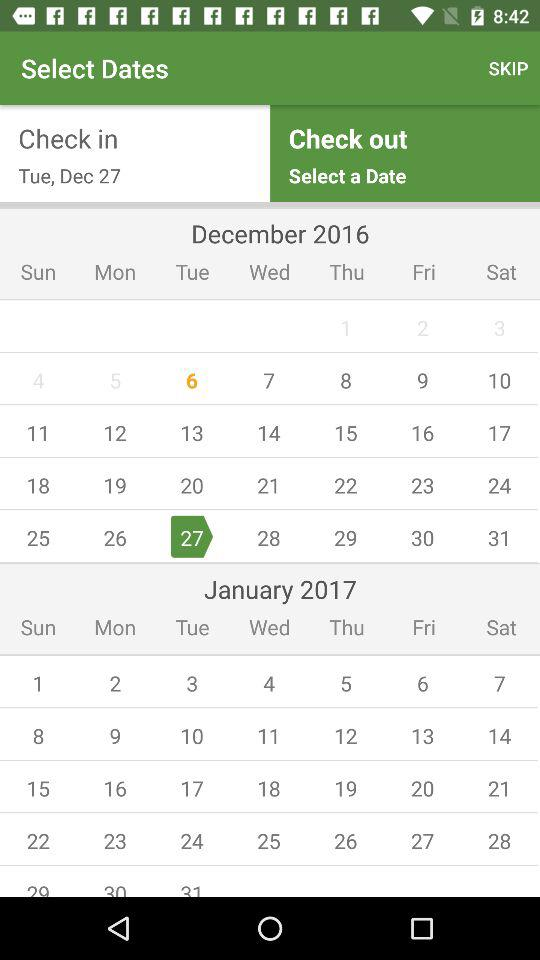What is the check-in date? The check-in date is Tuesday, December 27. 